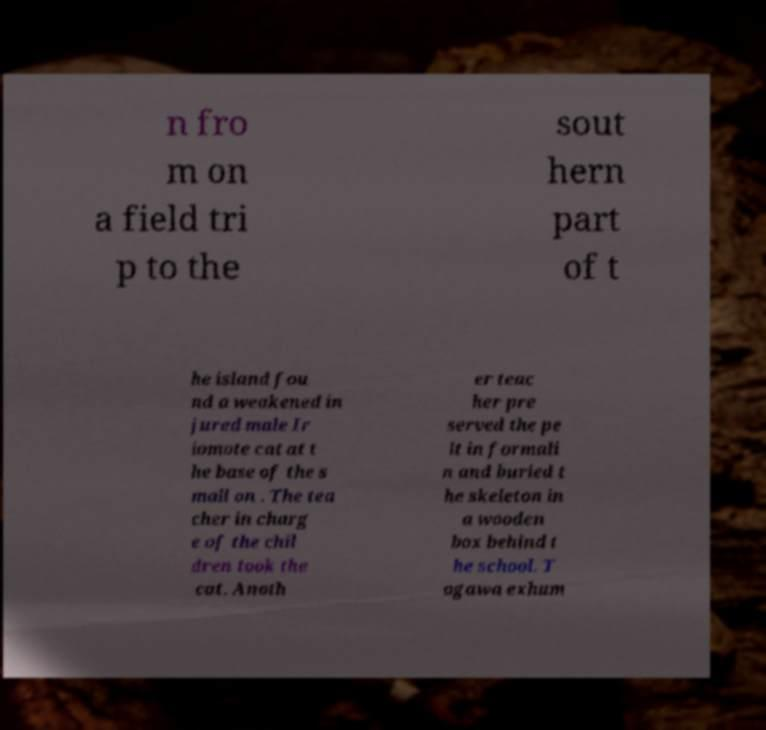Please read and relay the text visible in this image. What does it say? n fro m on a field tri p to the sout hern part of t he island fou nd a weakened in jured male Ir iomote cat at t he base of the s mall on . The tea cher in charg e of the chil dren took the cat. Anoth er teac her pre served the pe lt in formali n and buried t he skeleton in a wooden box behind t he school. T ogawa exhum 